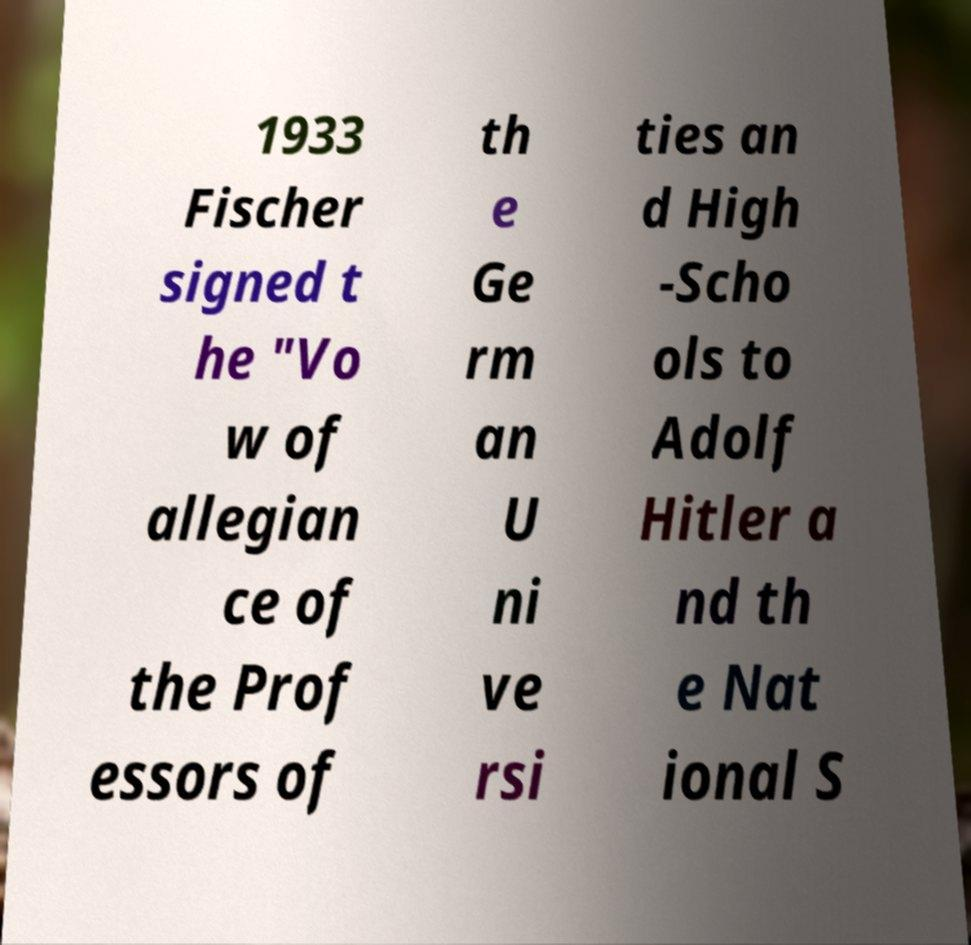Can you read and provide the text displayed in the image?This photo seems to have some interesting text. Can you extract and type it out for me? 1933 Fischer signed t he "Vo w of allegian ce of the Prof essors of th e Ge rm an U ni ve rsi ties an d High -Scho ols to Adolf Hitler a nd th e Nat ional S 